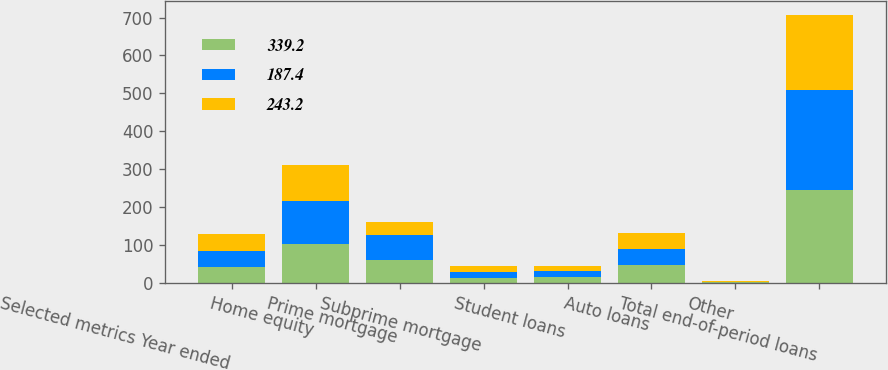<chart> <loc_0><loc_0><loc_500><loc_500><stacked_bar_chart><ecel><fcel>Selected metrics Year ended<fcel>Home equity<fcel>Prime mortgage<fcel>Subprime mortgage<fcel>Student loans<fcel>Auto loans<fcel>Other<fcel>Total end-of-period loans<nl><fcel>339.2<fcel>42.3<fcel>101.4<fcel>59.4<fcel>12.5<fcel>15.8<fcel>46<fcel>0.7<fcel>244.3<nl><fcel>187.4<fcel>42.3<fcel>114.3<fcel>65.2<fcel>15.3<fcel>15.9<fcel>42.6<fcel>1.3<fcel>263.6<nl><fcel>243.2<fcel>42.3<fcel>94.8<fcel>34<fcel>15.5<fcel>11<fcel>42.3<fcel>2.1<fcel>199.7<nl></chart> 